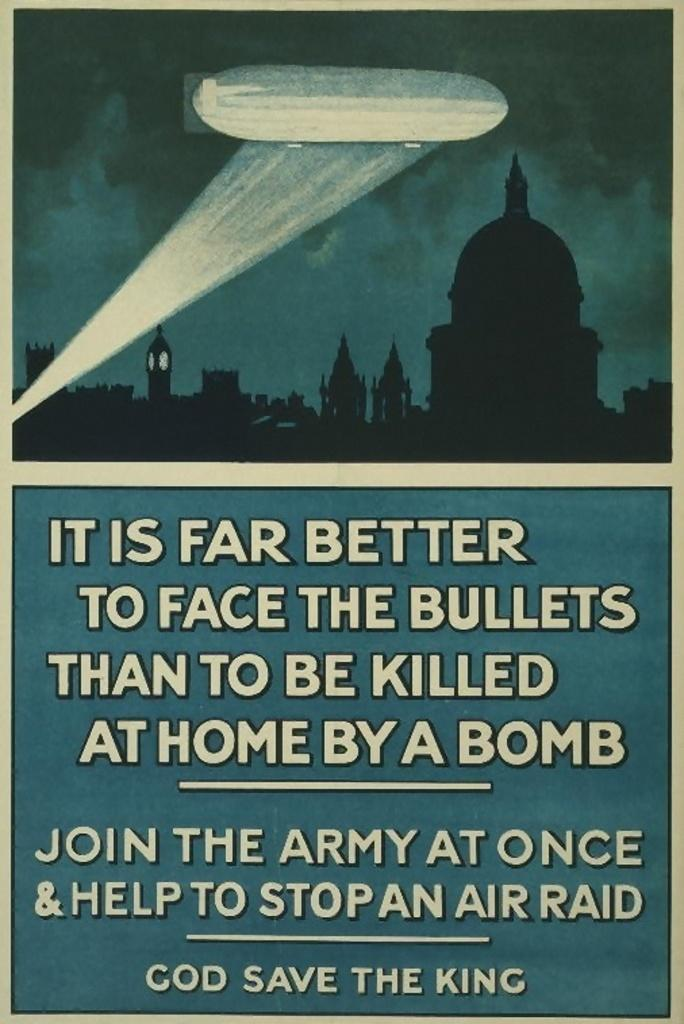<image>
Write a terse but informative summary of the picture. A join the army propaganda poster that says God Save the King on the bottom. 